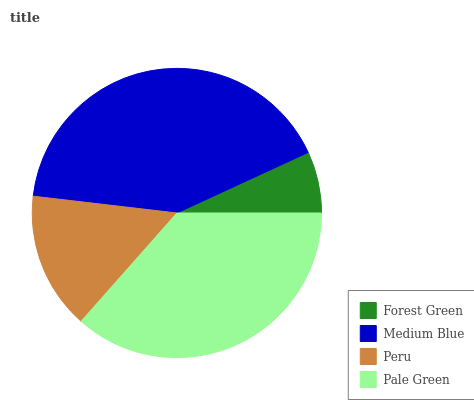Is Forest Green the minimum?
Answer yes or no. Yes. Is Medium Blue the maximum?
Answer yes or no. Yes. Is Peru the minimum?
Answer yes or no. No. Is Peru the maximum?
Answer yes or no. No. Is Medium Blue greater than Peru?
Answer yes or no. Yes. Is Peru less than Medium Blue?
Answer yes or no. Yes. Is Peru greater than Medium Blue?
Answer yes or no. No. Is Medium Blue less than Peru?
Answer yes or no. No. Is Pale Green the high median?
Answer yes or no. Yes. Is Peru the low median?
Answer yes or no. Yes. Is Peru the high median?
Answer yes or no. No. Is Pale Green the low median?
Answer yes or no. No. 